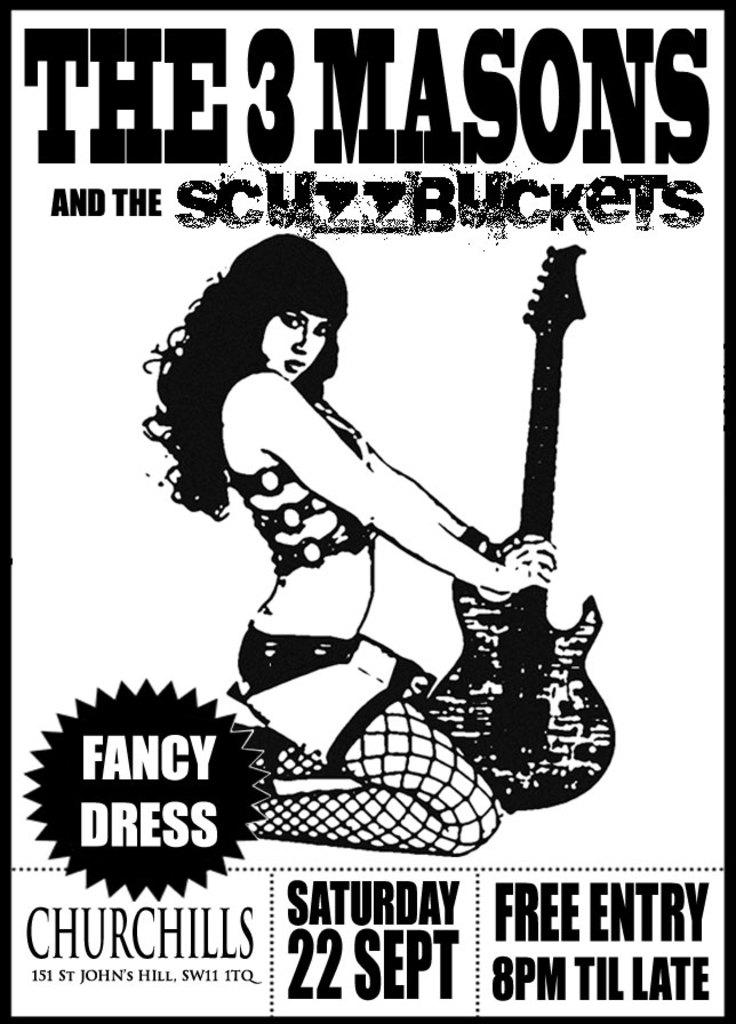<image>
Write a terse but informative summary of the picture. an advertisement for the 3 masions and the schzzbuckets at the churchills 